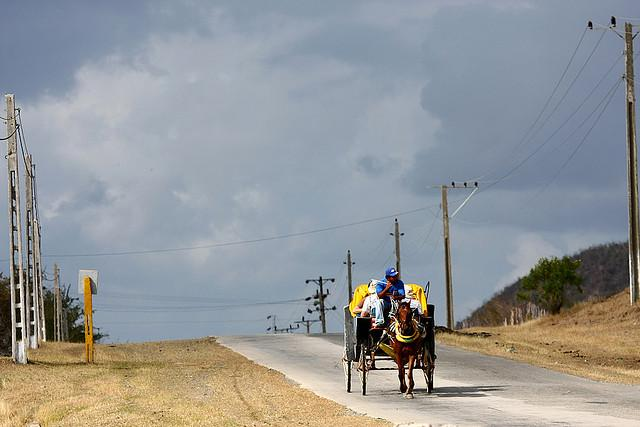What is the tallest item here? Please explain your reasoning. telephone pole. Is the tallest thing connected to the planet. the highest would be the clouds. 